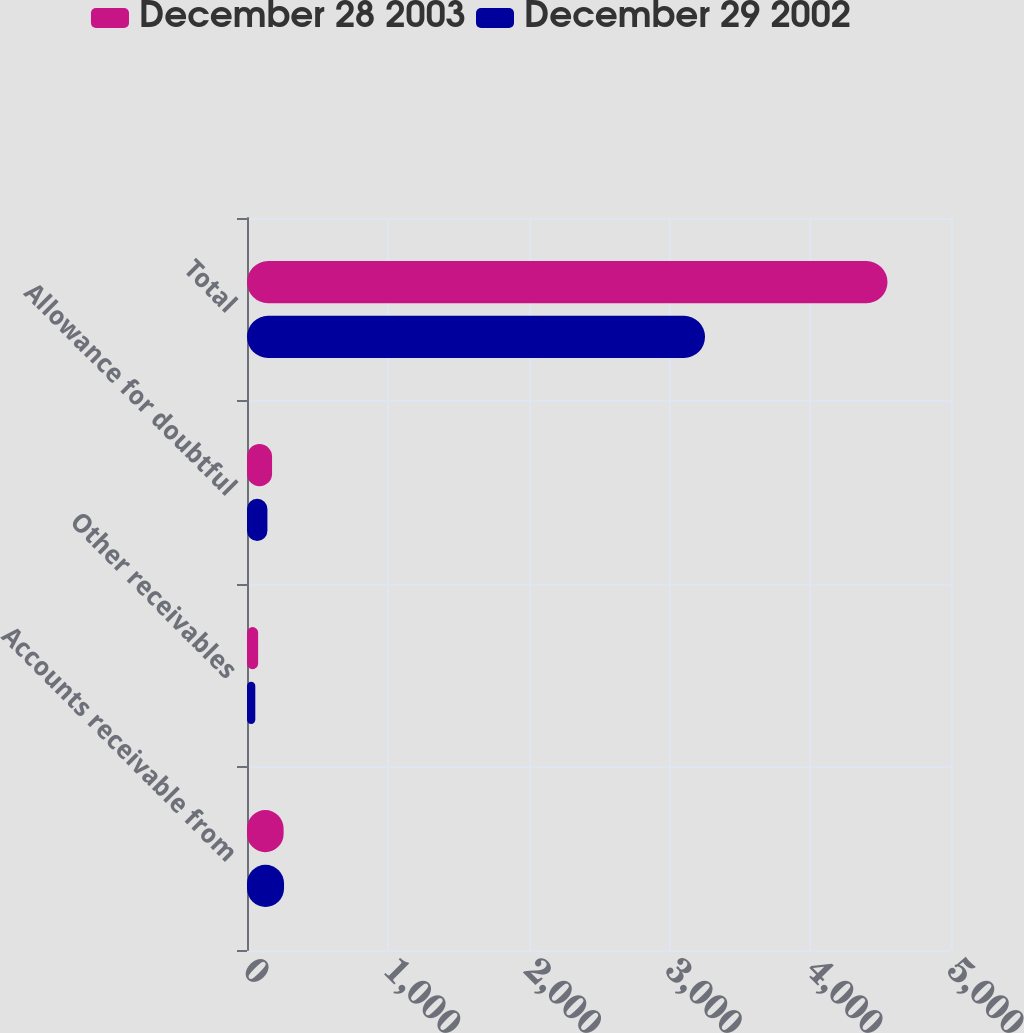<chart> <loc_0><loc_0><loc_500><loc_500><stacked_bar_chart><ecel><fcel>Accounts receivable from<fcel>Other receivables<fcel>Allowance for doubtful<fcel>Total<nl><fcel>December 28 2003<fcel>260<fcel>79<fcel>178<fcel>4549<nl><fcel>December 29 2002<fcel>263<fcel>59<fcel>145<fcel>3253<nl></chart> 